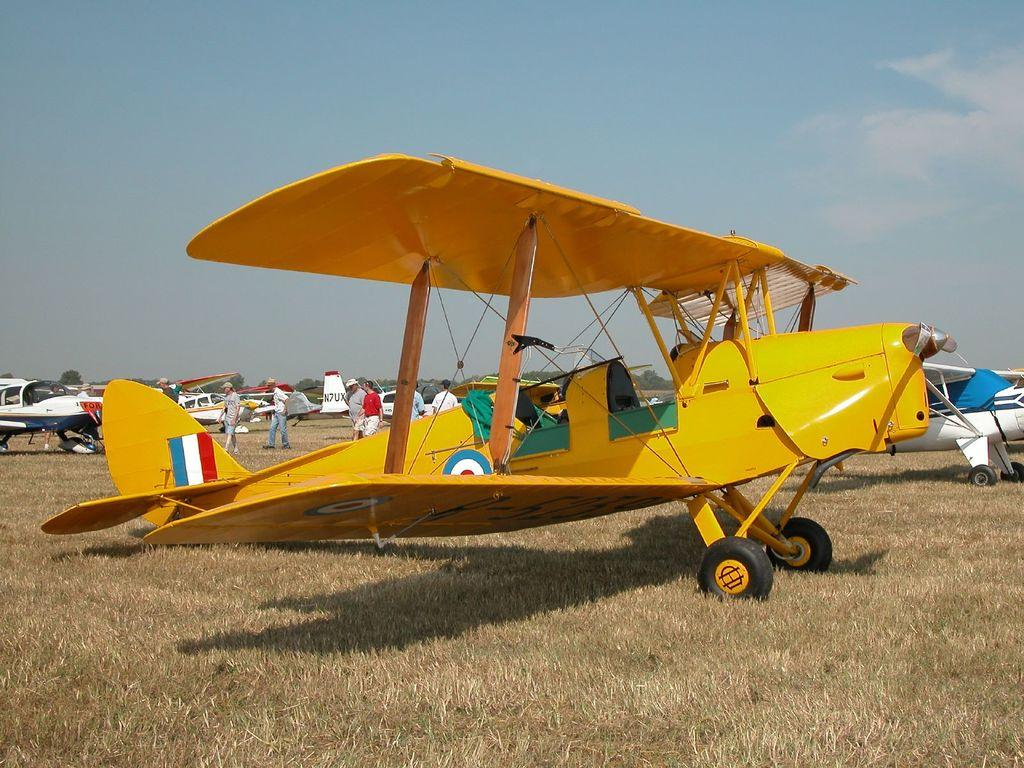What is the primary setting of the image? There is a ground in the image. What can be seen on the ground? There are parked flights on the ground. How can the flights be distinguished from one another? The flights are of different colors. What are some people doing in the image? Some people are walking between the flights. Where is the faucet located in the image? There is no faucet present in the image. Can you see a basketball being played in the image? There is no basketball or any indication of a game being played in the image; it features parked flights and people walking between them. 